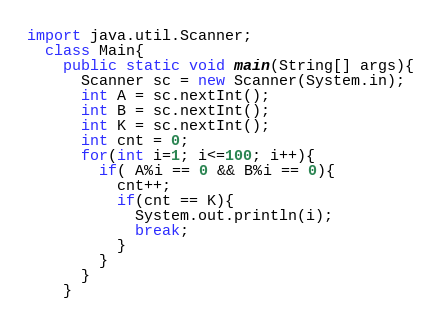<code> <loc_0><loc_0><loc_500><loc_500><_Java_>import java.util.Scanner;
  class Main{
    public static void main(String[] args){
      Scanner sc = new Scanner(System.in);
      int A = sc.nextInt();
      int B = sc.nextInt();
      int K = sc.nextInt();
      int cnt = 0;
      for(int i=1; i<=100; i++){
        if( A%i == 0 && B%i == 0){
          cnt++;
          if(cnt == K){
            System.out.println(i);
            break;
          }
        }
      }
    }

</code> 